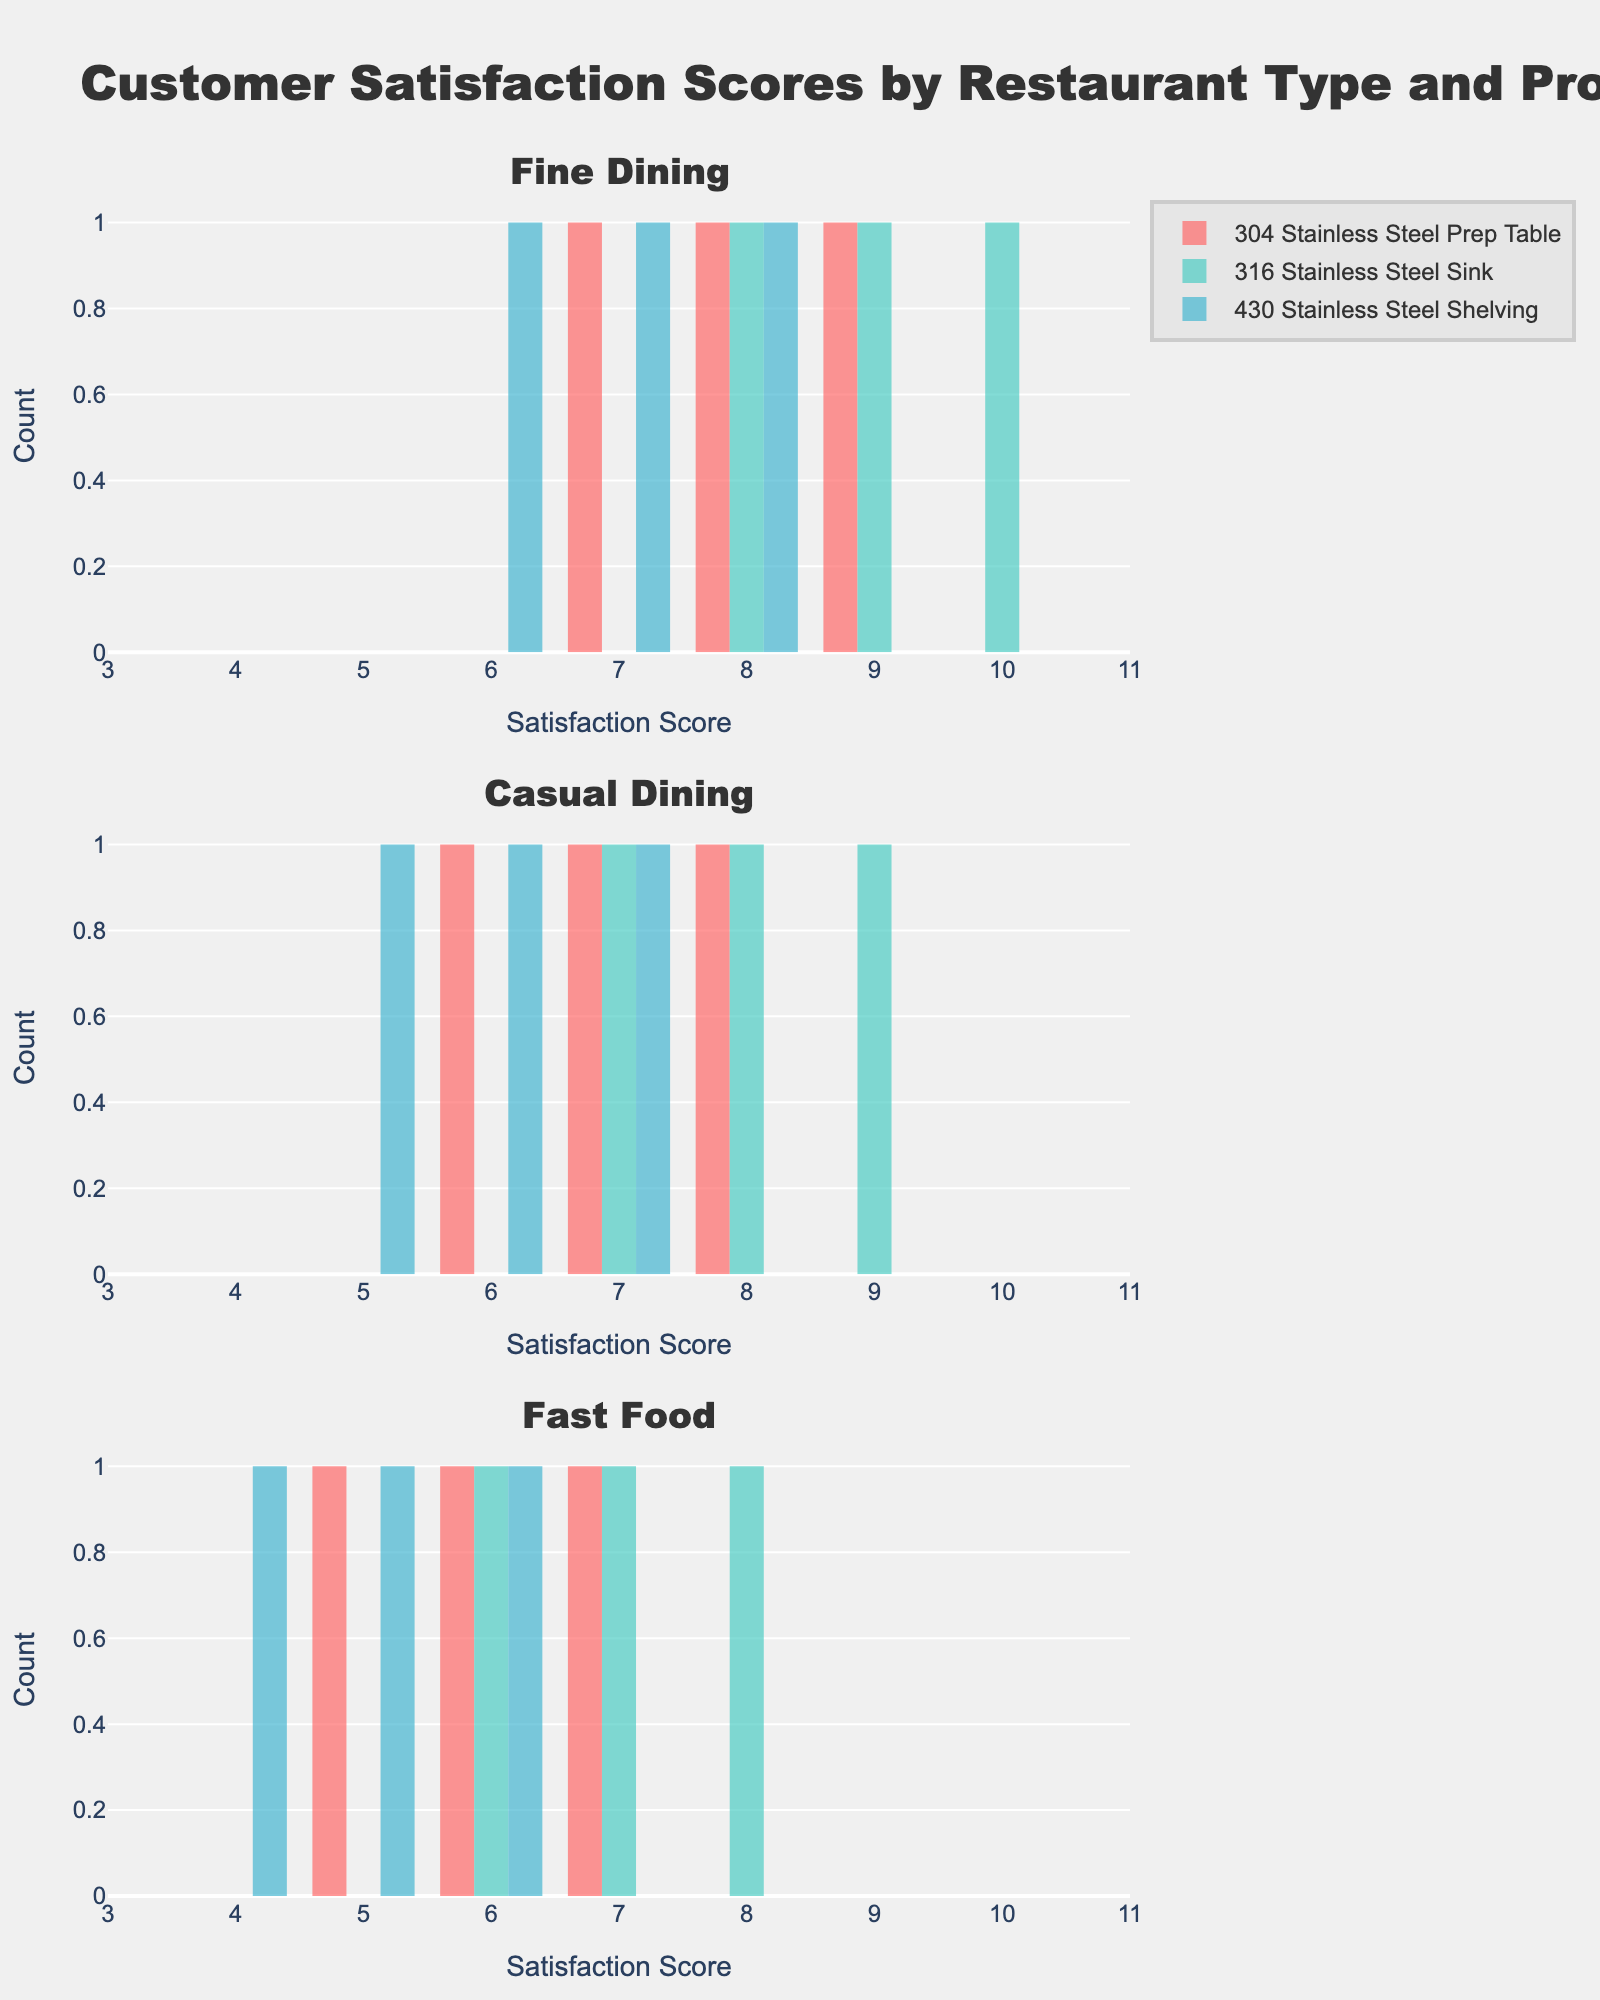Do the satisfaction scores of 304 Stainless Steel Prep Table in Fine Dining have more variety compared to Casual Dining? Look at the range of satisfaction scores for 304 Stainless Steel Prep Table in both restaurant types. Fine Dining ranges from 7 to 9, while Casual Dining ranges from 6 to 8, meaning both have a similar variety.
Answer: No Which product in Fine Dining has the highest satisfaction scores on average? Examine the highest peaks of the histogram bars for each product in Fine Dining. The 316 Stainless Steel Sink has the highest individual score peaks at 9 and 10.
Answer: 316 Stainless Steel Sink Between Fine Dining and Casual Dining, which restaurant type has a higher spread of satisfaction scores for 430 Stainless Steel Shelving? Fine Dining's 430 Stainless Steel Shelving scores range from 6 to 8, while Casual Dining's range from 5 to 7, showing Fine Dining has a higher spread.
Answer: Fine Dining Is there a product in Fast Food that does not have any scores above 8? By inspecting the highest bins of the histogram bars for Fast Food, it is evident all products, including 430 Stainless Steel Shelving, 316 Stainless Steel Sink, and 304 Stainless Steel Prep Table, have scores not exceeding 8.
Answer: Yes Which product in Casual Dining has the most consistent satisfaction scores? Consistency can be seen through narrow score ranges. The 430 Stainless Steel Shelving in Casual Dining clusters tightly around scores 5 to 7.
Answer: 430 Stainless Steel Shelving Which restaurant type has the most varied customer satisfaction scores overall? Compare the spread of satisfaction scores across all restaurant types. Fast Food has the widest range (4 to 8), indicating the most variation.
Answer: Fast Food What is the most frequently observed score for Fine Dining's 430 Stainless Steel Shelving? Check the histogram bar with the highest frequency for 430 Stainless Steel Shelving in Fine Dining, which centers at score 7.
Answer: 7 Does Casual Dining have any product with a satisfaction score of 10? Review the histogram ranges for each product in Casual Dining; no bars reach a score of 10.
Answer: No Which product in Fast Food has the lowest possible satisfaction score? Observe the lowest histogram bar for each product in Fast Food. The 430 Stainless Steel Shelving has scores starting from 4.
Answer: 430 Stainless Steel Shelving 